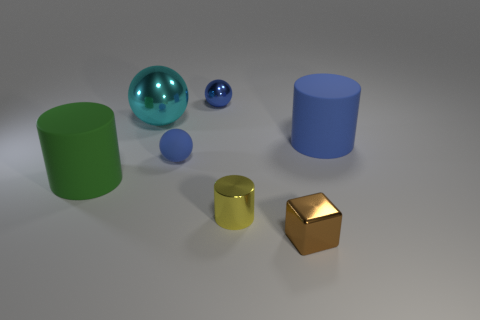Add 1 blue rubber cylinders. How many objects exist? 8 Subtract all cylinders. How many objects are left? 4 Subtract all metal things. Subtract all small shiny balls. How many objects are left? 2 Add 6 tiny shiny blocks. How many tiny shiny blocks are left? 7 Add 7 large cyan things. How many large cyan things exist? 8 Subtract 1 blue cylinders. How many objects are left? 6 